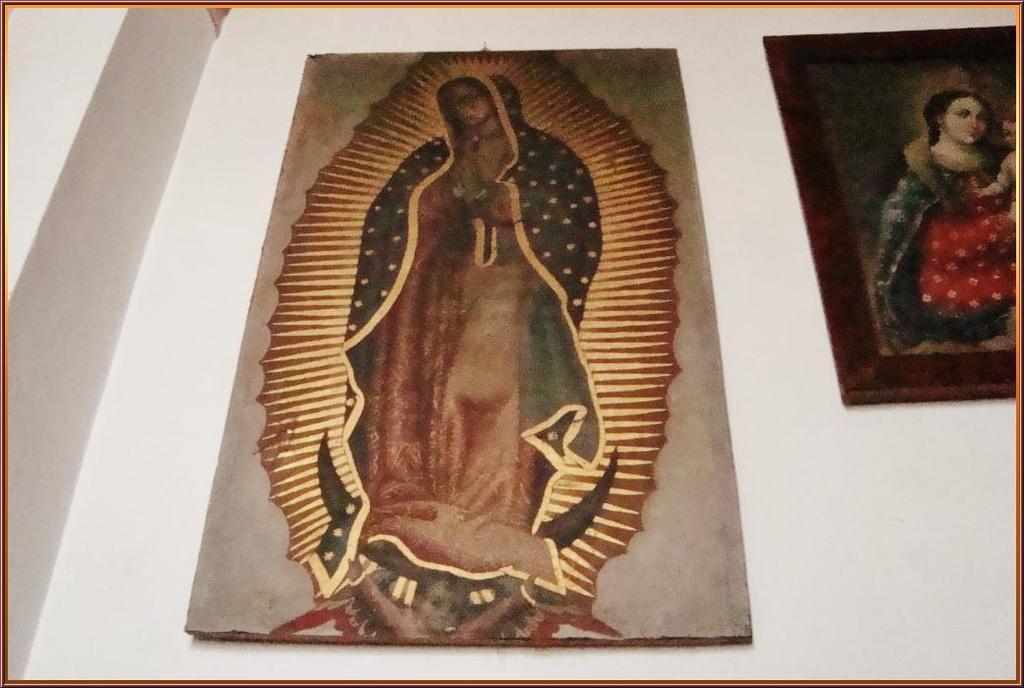In one or two sentences, can you explain what this image depicts? This is an edited picture. In this image there are frames on the wall and there are paintings of a group of people on the frames. At the back there is a wall. 